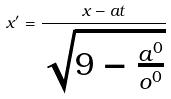<formula> <loc_0><loc_0><loc_500><loc_500>x ^ { \prime } = \frac { x - a t } { \sqrt { 9 - \frac { a ^ { 0 } } { o ^ { 0 } } } }</formula> 